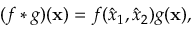<formula> <loc_0><loc_0><loc_500><loc_500>( f * g ) ( x ) = f ( \hat { x } _ { 1 } , \hat { x } _ { 2 } ) g ( x ) ,</formula> 